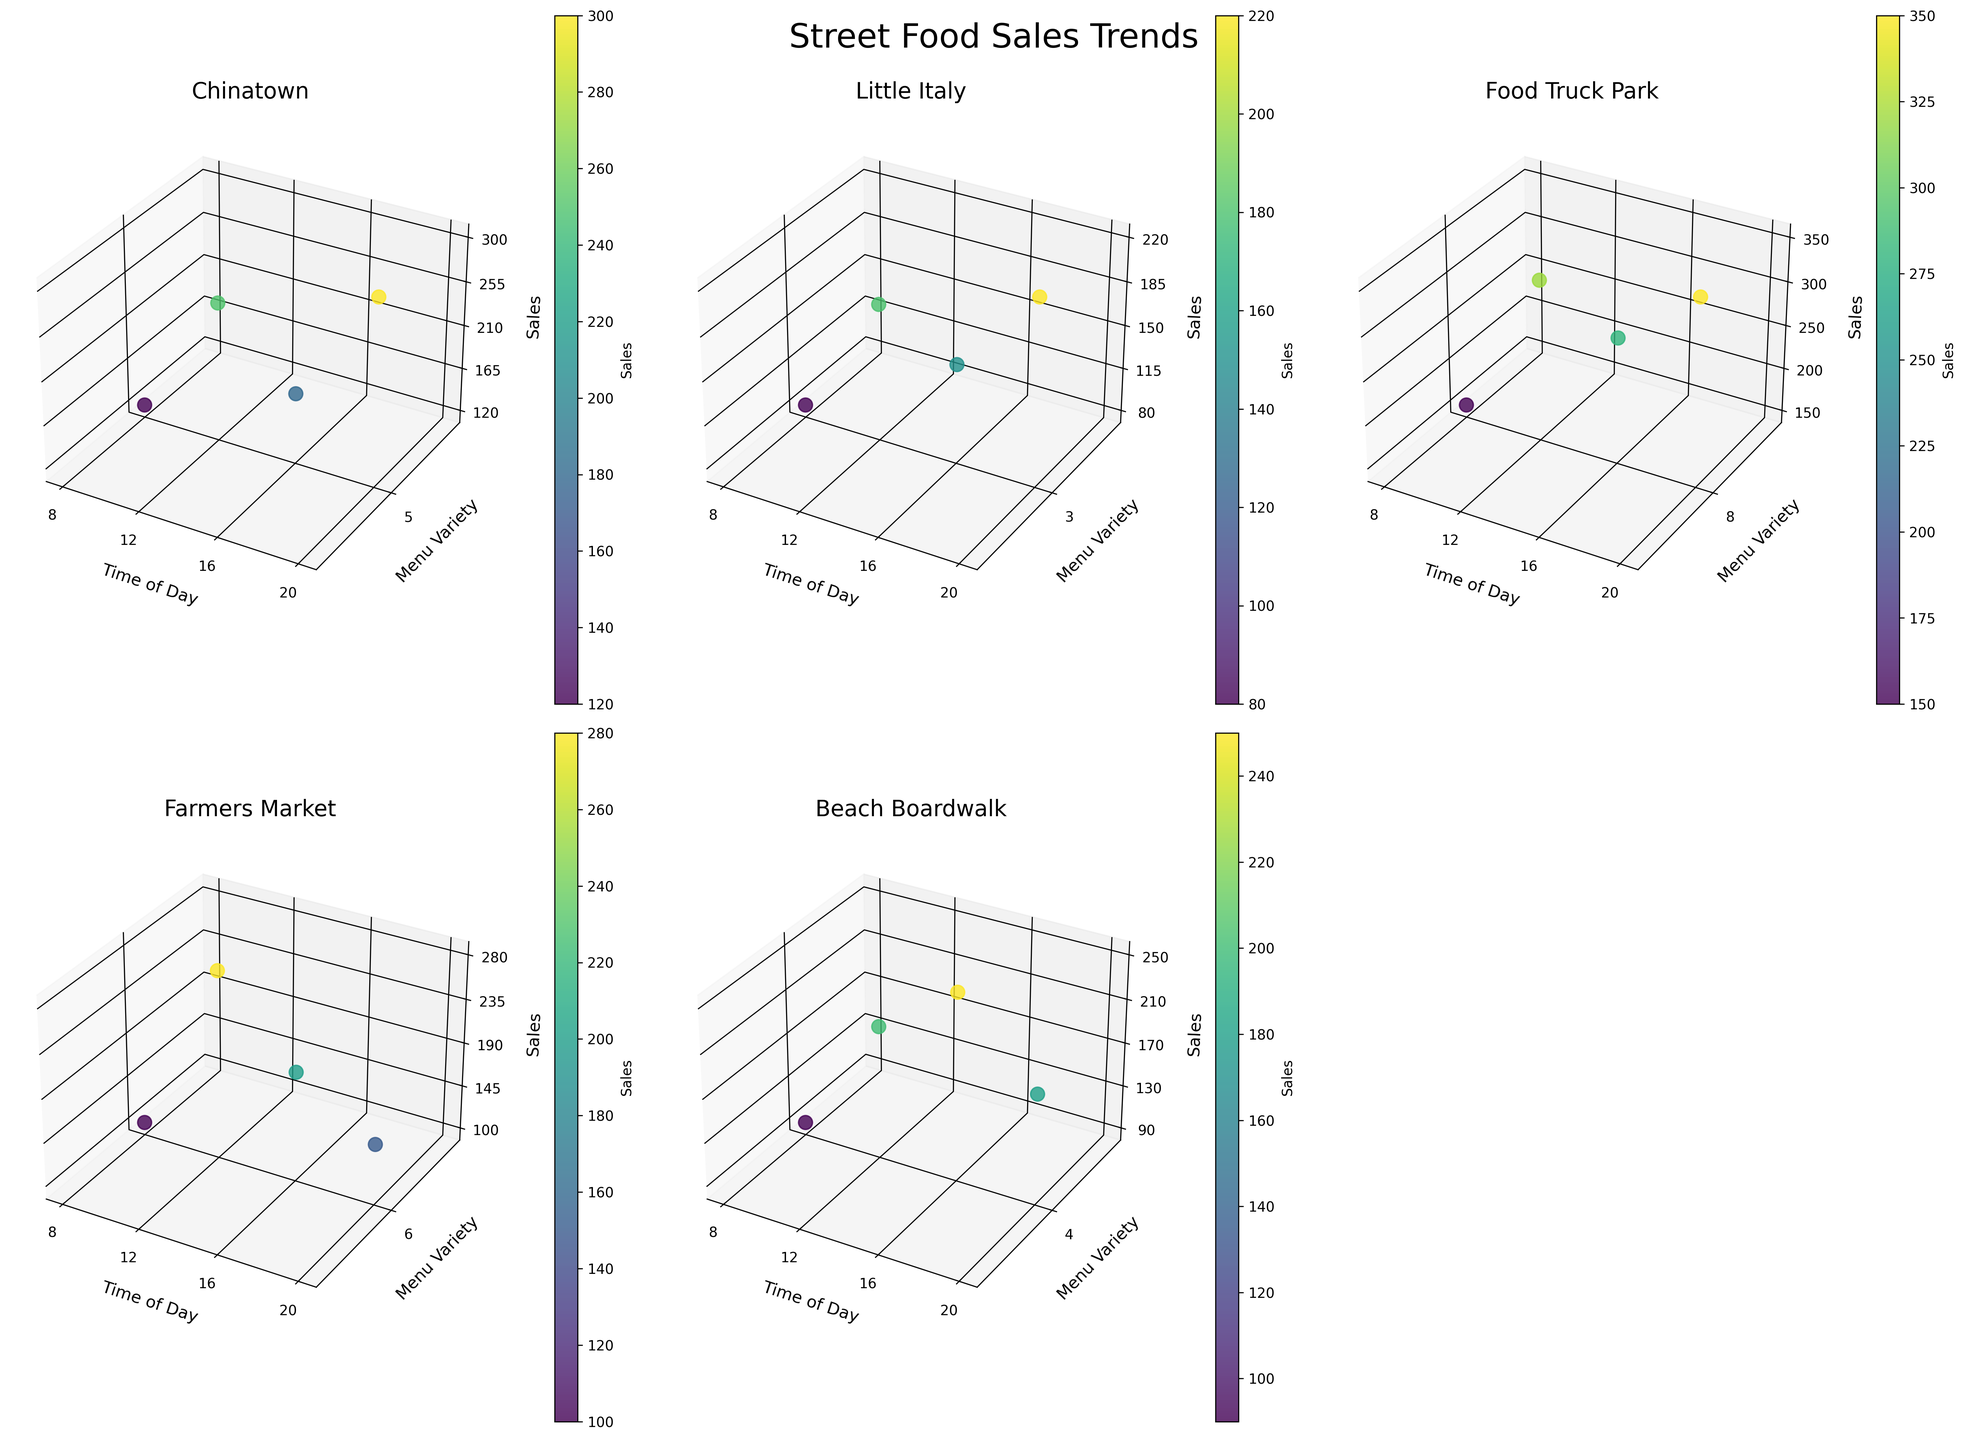what is the average sales value for street food vendors in Little Italy? To determine the average sales value in Little Italy, locate Little Italy's subplot and note the sales values (80, 180, 150, 220). Sum them up (80 + 180 + 150 + 220 = 630) and divide by the number of data points (4). Thus, the average sales is 630 / 4 = 157.5
Answer: 157.5 Which location has the highest sales at 12 PM? Examine the sales values for each location at 12 PM across all subplots. Chinatown is 250, Little Italy is 180, Food Truck Park is 320, Farmers Market is 280, and Beach Boardwalk is 200. The highest value is 320 at the Food Truck Park
Answer: Food Truck Park What is the title of the figure? The title is found at the top of the figure. The title of this figure is "Street Food Sales Trends."
Answer: Street Food Sales Trends Which location has the most significant variation in sales between the times of 8 AM and 8 PM? Calculate the sales difference between 8 AM and 8 PM for each location: Chinatown (300 - 120 = 180), Little Italy (220 - 80 = 140), Food Truck Park (350 - 150 = 200), Farmers Market (150 - 100 = 50), Beach Boardwalk (180 - 90 = 90). The most considerable variation is at Food Truck Park, with a difference of 200
Answer: Food Truck Park For Food Truck Park, at what time is the lowest sales value observed? Examine Food Truck Park's subplot and note the sales values at different times: 8 AM (150), 12 PM (320), 4 PM (280), 8 PM (350). The lowest value is 150 at 8 AM
Answer: 8 AM Which location has the highest variety in its menu? Check the y-axis labeled as "Menu Variety" in each subplot for the maximum values. Chinatown has 5, Little Italy has 3, Food Truck Park has 8, Farmers Market has 6, Beach Boardwalk has 4. The highest variety is 8 at Food Truck Park
Answer: Food Truck Park What is the menu variety range (difference between max and min) for Farmers Market throughout the day? Identify the menu variety values for Farmers Market: all values are 6. The range is calculated as max - min, which is 6 - 6 = 0
Answer: 0 How do the sales at 4 PM compare between Chinatown and Beach Boardwalk? Examine the sales values at 4 PM in the respective subplots: Chinatown is 180, Beach Boardwalk is 250. Compare these two values, where 250 (Beach Boardwalk) is higher than 180 (Chinatown)
Answer: Beach Boardwalk has higher sales at 4 PM Overall, which location shows the highest single sales value during the whole day? Review the maximum sales value in each subplot: Chinatown (300), Little Italy (220), Food Truck Park (350), Farmers Market (280), Beach Boardwalk (250). The highest single sales value is 350 at Food Truck Park
Answer: Food Truck Park At what time does Chinatown see its peak sales? Identify the highest sales value in Chinatown's subplot and note its corresponding time, which is 300 at 8 PM
Answer: 8 PM 